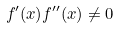<formula> <loc_0><loc_0><loc_500><loc_500>f ^ { \prime } ( x ) f ^ { \prime \prime } ( x ) \ne 0</formula> 